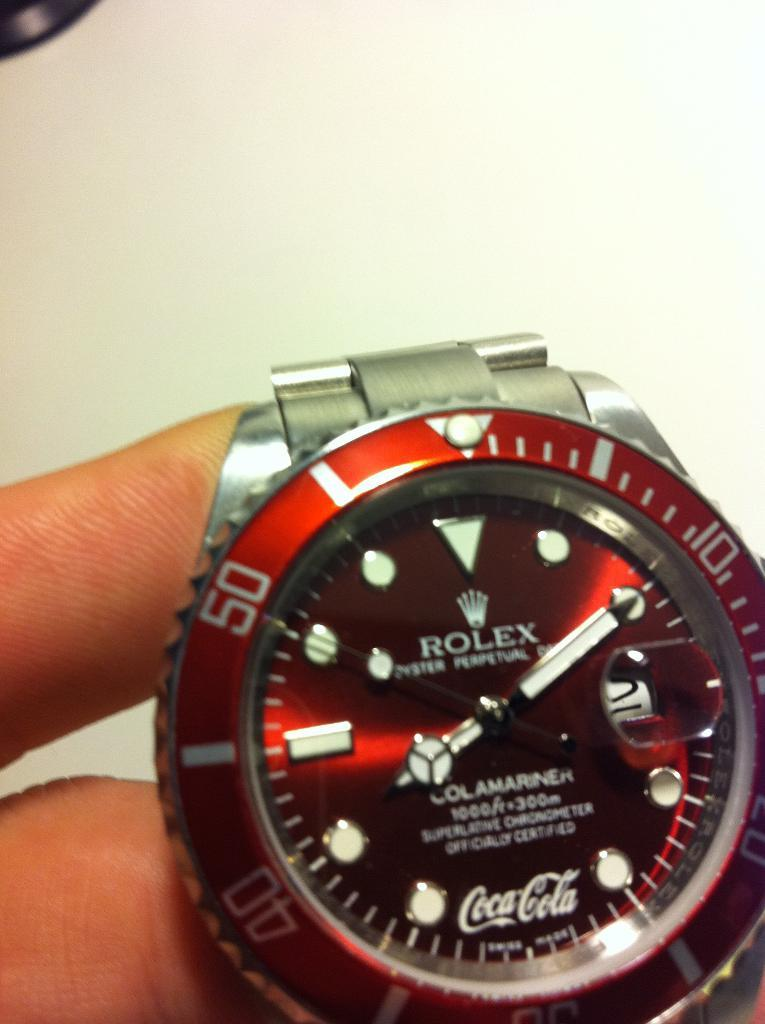Provide a one-sentence caption for the provided image. The face of a Rolex watch is red with the Coca Cola logo at the bottom. 